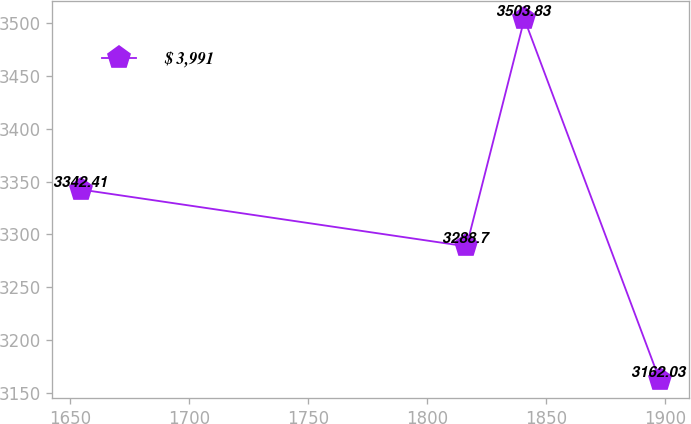<chart> <loc_0><loc_0><loc_500><loc_500><line_chart><ecel><fcel>$ 3,991<nl><fcel>1654.61<fcel>3342.41<nl><fcel>1816.48<fcel>3288.7<nl><fcel>1840.79<fcel>3503.83<nl><fcel>1897.71<fcel>3162.03<nl></chart> 